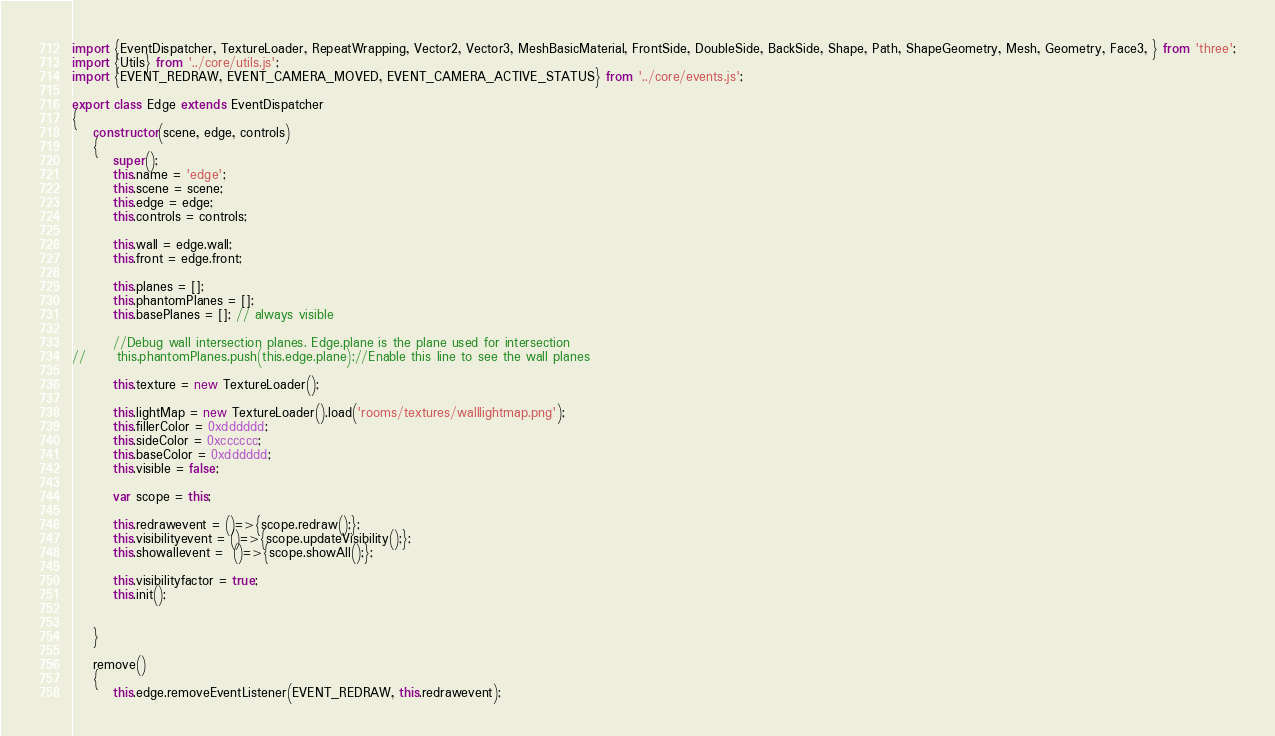<code> <loc_0><loc_0><loc_500><loc_500><_JavaScript_>import {EventDispatcher, TextureLoader, RepeatWrapping, Vector2, Vector3, MeshBasicMaterial, FrontSide, DoubleSide, BackSide, Shape, Path, ShapeGeometry, Mesh, Geometry, Face3, } from 'three';
import {Utils} from '../core/utils.js';
import {EVENT_REDRAW, EVENT_CAMERA_MOVED, EVENT_CAMERA_ACTIVE_STATUS} from '../core/events.js';

export class Edge extends EventDispatcher
{
	constructor(scene, edge, controls)
	{
		super();
		this.name = 'edge';
		this.scene = scene;
		this.edge = edge;
		this.controls = controls;

		this.wall = edge.wall;
		this.front = edge.front;

		this.planes = [];
		this.phantomPlanes = [];
		this.basePlanes = []; // always visible
		
		//Debug wall intersection planes. Edge.plane is the plane used for intersection
//		this.phantomPlanes.push(this.edge.plane);//Enable this line to see the wall planes
		
		this.texture = new TextureLoader();

		this.lightMap = new TextureLoader().load('rooms/textures/walllightmap.png');
		this.fillerColor = 0xdddddd;
		this.sideColor = 0xcccccc;
		this.baseColor = 0xdddddd;
		this.visible = false;

		var scope = this;

		this.redrawevent = ()=>{scope.redraw();};
		this.visibilityevent = ()=>{scope.updateVisibility();};
		this.showallevent =  ()=>{scope.showAll();};
		
		this.visibilityfactor = true;
		this.init();
		
		
	}

	remove()
	{
		this.edge.removeEventListener(EVENT_REDRAW, this.redrawevent);</code> 